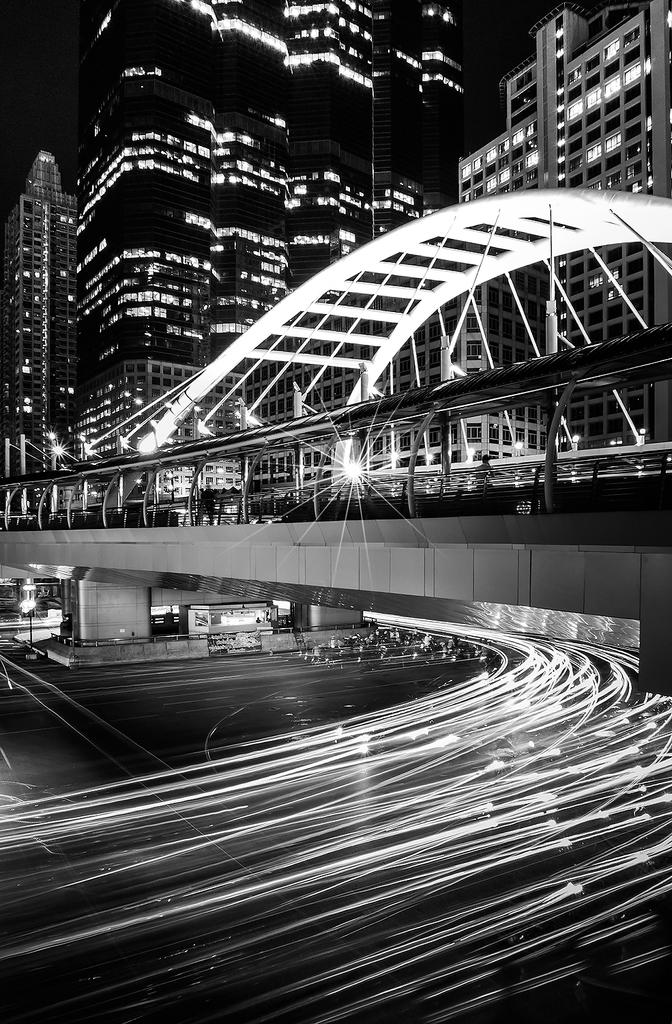What type of pathway is visible in the image? There is a road in the image. What structure can be seen crossing over the road? There is a bridge in the image. What type of man-made structures are present in the image? There are buildings in the image. What type of illumination is present in the image? There are lights in the image. What other objects can be seen in the image? There are some objects in the image. How would you describe the overall lighting condition in the image? The background of the image is dark. What shape is the meeting taking in the image? There is no meeting present in the image, so it is not possible to determine the shape of a meeting. 